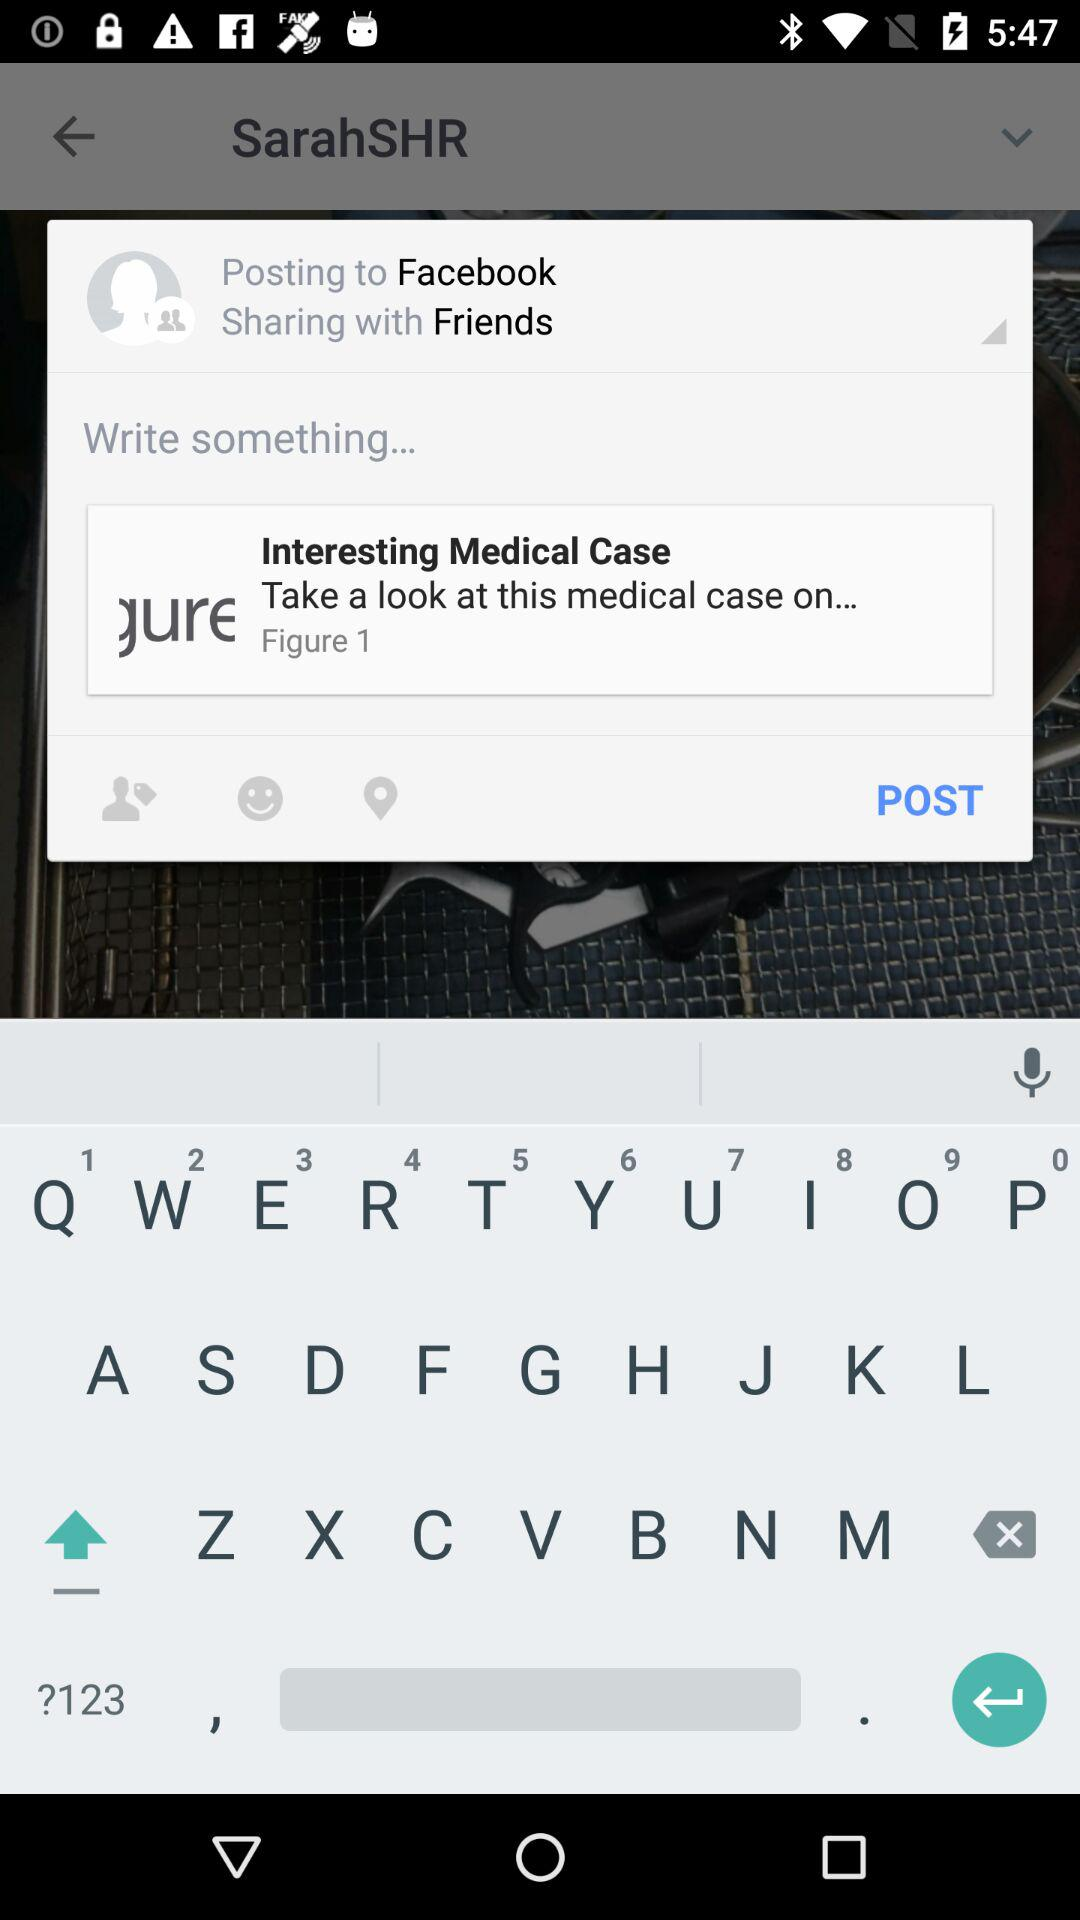What is the email address? The email address is appcrawler1@gmail.com. 